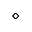<formula> <loc_0><loc_0><loc_500><loc_500>\diamond</formula> 